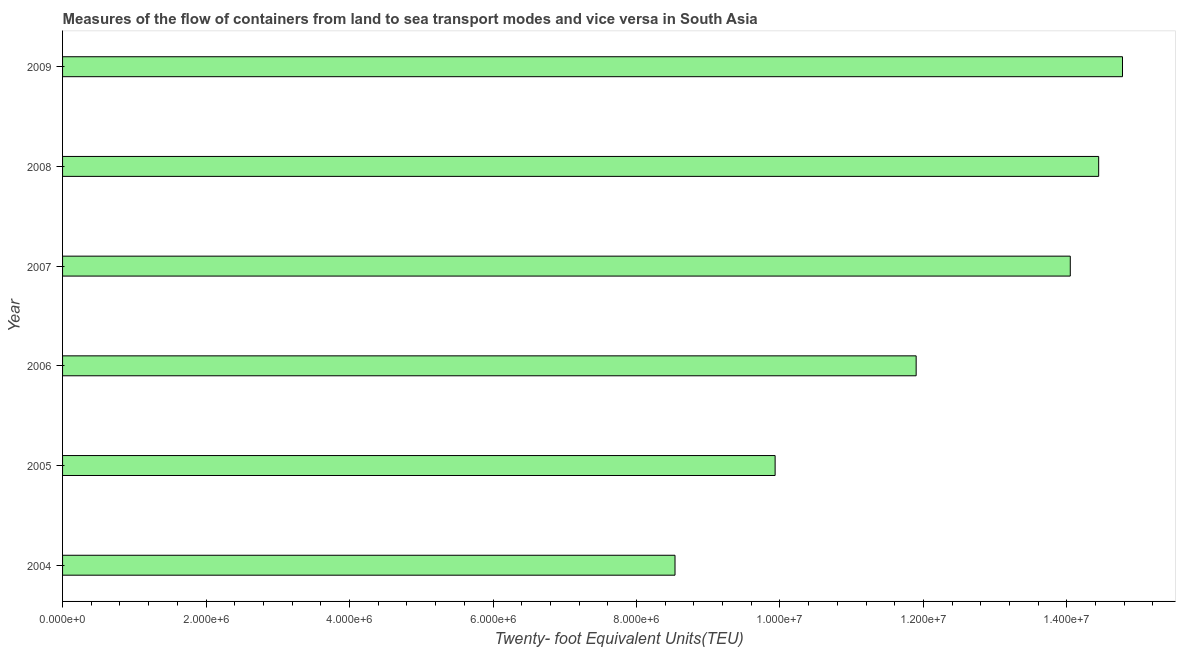Does the graph contain any zero values?
Provide a succinct answer. No. Does the graph contain grids?
Provide a short and direct response. No. What is the title of the graph?
Give a very brief answer. Measures of the flow of containers from land to sea transport modes and vice versa in South Asia. What is the label or title of the X-axis?
Offer a very short reply. Twenty- foot Equivalent Units(TEU). What is the label or title of the Y-axis?
Give a very brief answer. Year. What is the container port traffic in 2004?
Provide a short and direct response. 8.54e+06. Across all years, what is the maximum container port traffic?
Give a very brief answer. 1.48e+07. Across all years, what is the minimum container port traffic?
Provide a short and direct response. 8.54e+06. In which year was the container port traffic maximum?
Offer a very short reply. 2009. What is the sum of the container port traffic?
Provide a succinct answer. 7.36e+07. What is the difference between the container port traffic in 2004 and 2008?
Give a very brief answer. -5.91e+06. What is the average container port traffic per year?
Give a very brief answer. 1.23e+07. What is the median container port traffic?
Offer a terse response. 1.30e+07. What is the ratio of the container port traffic in 2005 to that in 2009?
Ensure brevity in your answer.  0.67. What is the difference between the highest and the second highest container port traffic?
Keep it short and to the point. 3.32e+05. What is the difference between the highest and the lowest container port traffic?
Offer a very short reply. 6.24e+06. In how many years, is the container port traffic greater than the average container port traffic taken over all years?
Provide a succinct answer. 3. How many bars are there?
Ensure brevity in your answer.  6. Are the values on the major ticks of X-axis written in scientific E-notation?
Ensure brevity in your answer.  Yes. What is the Twenty- foot Equivalent Units(TEU) of 2004?
Make the answer very short. 8.54e+06. What is the Twenty- foot Equivalent Units(TEU) in 2005?
Provide a succinct answer. 9.93e+06. What is the Twenty- foot Equivalent Units(TEU) in 2006?
Your answer should be compact. 1.19e+07. What is the Twenty- foot Equivalent Units(TEU) in 2007?
Offer a terse response. 1.40e+07. What is the Twenty- foot Equivalent Units(TEU) of 2008?
Your answer should be compact. 1.44e+07. What is the Twenty- foot Equivalent Units(TEU) in 2009?
Give a very brief answer. 1.48e+07. What is the difference between the Twenty- foot Equivalent Units(TEU) in 2004 and 2005?
Provide a succinct answer. -1.40e+06. What is the difference between the Twenty- foot Equivalent Units(TEU) in 2004 and 2006?
Make the answer very short. -3.36e+06. What is the difference between the Twenty- foot Equivalent Units(TEU) in 2004 and 2007?
Give a very brief answer. -5.51e+06. What is the difference between the Twenty- foot Equivalent Units(TEU) in 2004 and 2008?
Provide a short and direct response. -5.91e+06. What is the difference between the Twenty- foot Equivalent Units(TEU) in 2004 and 2009?
Provide a succinct answer. -6.24e+06. What is the difference between the Twenty- foot Equivalent Units(TEU) in 2005 and 2006?
Give a very brief answer. -1.97e+06. What is the difference between the Twenty- foot Equivalent Units(TEU) in 2005 and 2007?
Give a very brief answer. -4.11e+06. What is the difference between the Twenty- foot Equivalent Units(TEU) in 2005 and 2008?
Your response must be concise. -4.51e+06. What is the difference between the Twenty- foot Equivalent Units(TEU) in 2005 and 2009?
Your answer should be very brief. -4.84e+06. What is the difference between the Twenty- foot Equivalent Units(TEU) in 2006 and 2007?
Offer a very short reply. -2.15e+06. What is the difference between the Twenty- foot Equivalent Units(TEU) in 2006 and 2008?
Your answer should be compact. -2.54e+06. What is the difference between the Twenty- foot Equivalent Units(TEU) in 2006 and 2009?
Make the answer very short. -2.88e+06. What is the difference between the Twenty- foot Equivalent Units(TEU) in 2007 and 2008?
Make the answer very short. -3.96e+05. What is the difference between the Twenty- foot Equivalent Units(TEU) in 2007 and 2009?
Offer a terse response. -7.28e+05. What is the difference between the Twenty- foot Equivalent Units(TEU) in 2008 and 2009?
Ensure brevity in your answer.  -3.32e+05. What is the ratio of the Twenty- foot Equivalent Units(TEU) in 2004 to that in 2005?
Provide a succinct answer. 0.86. What is the ratio of the Twenty- foot Equivalent Units(TEU) in 2004 to that in 2006?
Ensure brevity in your answer.  0.72. What is the ratio of the Twenty- foot Equivalent Units(TEU) in 2004 to that in 2007?
Your response must be concise. 0.61. What is the ratio of the Twenty- foot Equivalent Units(TEU) in 2004 to that in 2008?
Your answer should be very brief. 0.59. What is the ratio of the Twenty- foot Equivalent Units(TEU) in 2004 to that in 2009?
Keep it short and to the point. 0.58. What is the ratio of the Twenty- foot Equivalent Units(TEU) in 2005 to that in 2006?
Provide a succinct answer. 0.83. What is the ratio of the Twenty- foot Equivalent Units(TEU) in 2005 to that in 2007?
Make the answer very short. 0.71. What is the ratio of the Twenty- foot Equivalent Units(TEU) in 2005 to that in 2008?
Offer a terse response. 0.69. What is the ratio of the Twenty- foot Equivalent Units(TEU) in 2005 to that in 2009?
Offer a very short reply. 0.67. What is the ratio of the Twenty- foot Equivalent Units(TEU) in 2006 to that in 2007?
Provide a short and direct response. 0.85. What is the ratio of the Twenty- foot Equivalent Units(TEU) in 2006 to that in 2008?
Your answer should be compact. 0.82. What is the ratio of the Twenty- foot Equivalent Units(TEU) in 2006 to that in 2009?
Provide a short and direct response. 0.81. What is the ratio of the Twenty- foot Equivalent Units(TEU) in 2007 to that in 2009?
Keep it short and to the point. 0.95. 